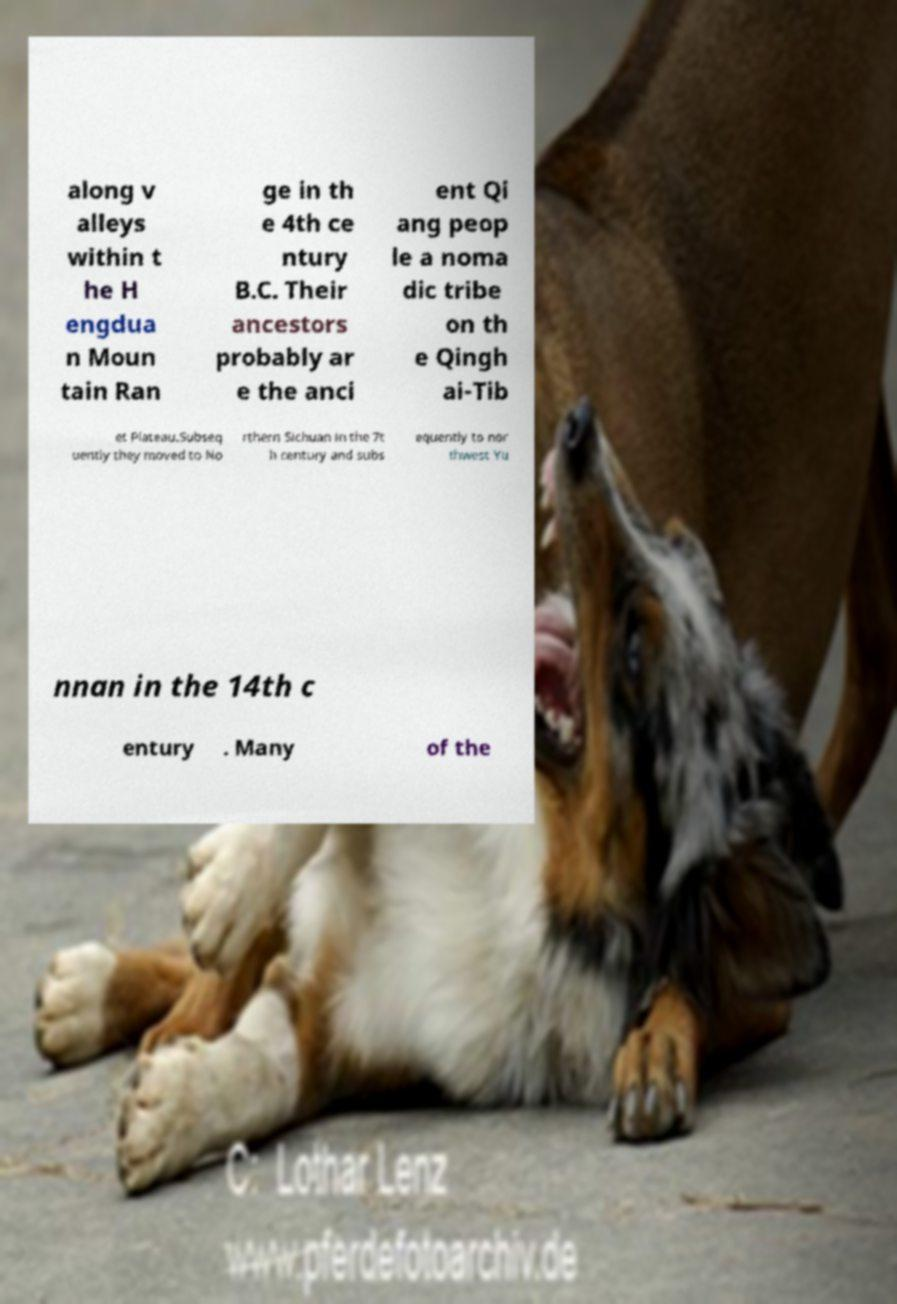What messages or text are displayed in this image? I need them in a readable, typed format. along v alleys within t he H engdua n Moun tain Ran ge in th e 4th ce ntury B.C. Their ancestors probably ar e the anci ent Qi ang peop le a noma dic tribe on th e Qingh ai-Tib et Plateau.Subseq uently they moved to No rthern Sichuan in the 7t h century and subs equently to nor thwest Yu nnan in the 14th c entury . Many of the 